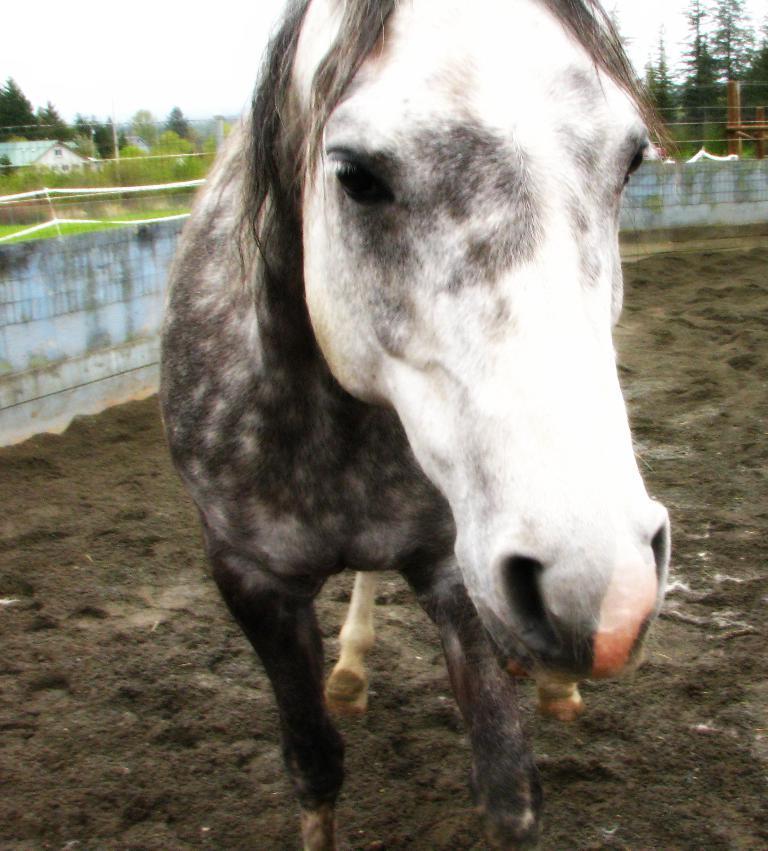Could you give a brief overview of what you see in this image? In the image in the center we can see one horse,which is in black and white color. In the background we can see the sky,clouds,trees,poles,building,wall,roof,fence etc. 